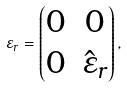Convert formula to latex. <formula><loc_0><loc_0><loc_500><loc_500>\varepsilon _ { r } = \begin{pmatrix} 0 & 0 \\ 0 & \hat { \varepsilon } _ { r } \end{pmatrix} ,</formula> 